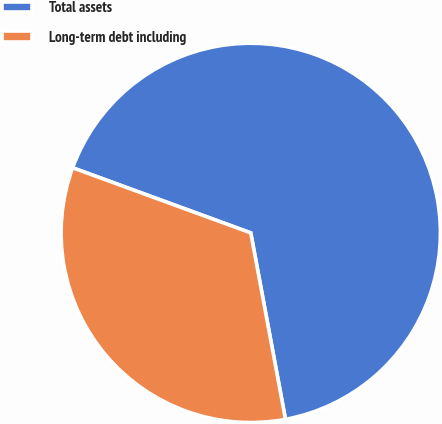Convert chart. <chart><loc_0><loc_0><loc_500><loc_500><pie_chart><fcel>Total assets<fcel>Long-term debt including<nl><fcel>66.49%<fcel>33.51%<nl></chart> 